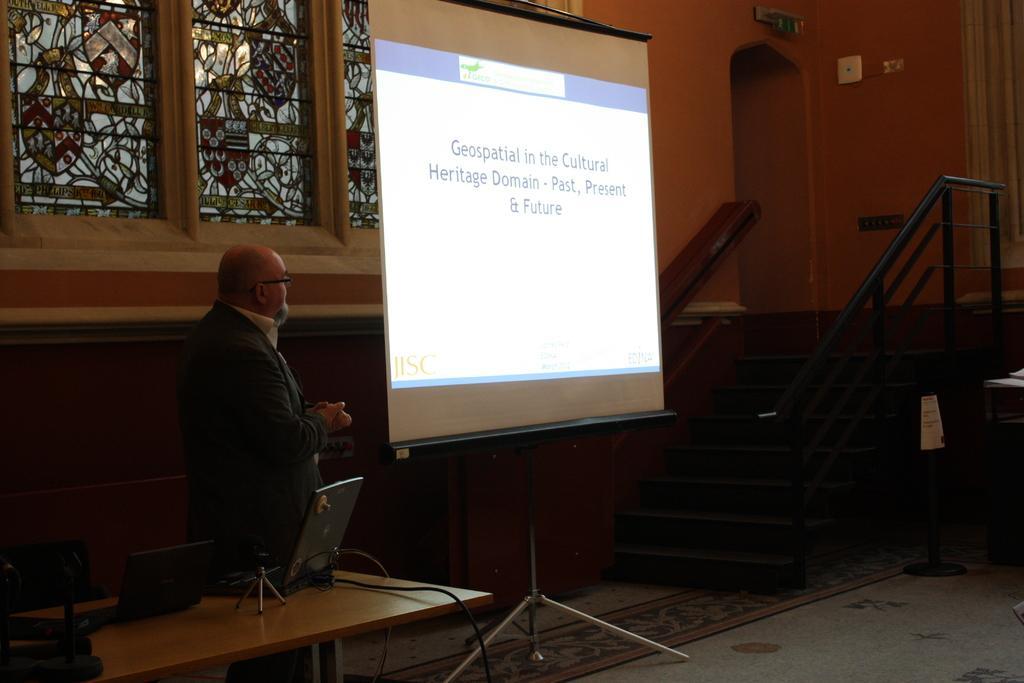Please provide a concise description of this image. In this picture there is a man who is standing at the left side of the image, it seems he is explaining something with the projector screen, there are stairs at the right side of the image and there are windows at the left side of the image and there are laptops on the table before the man. 